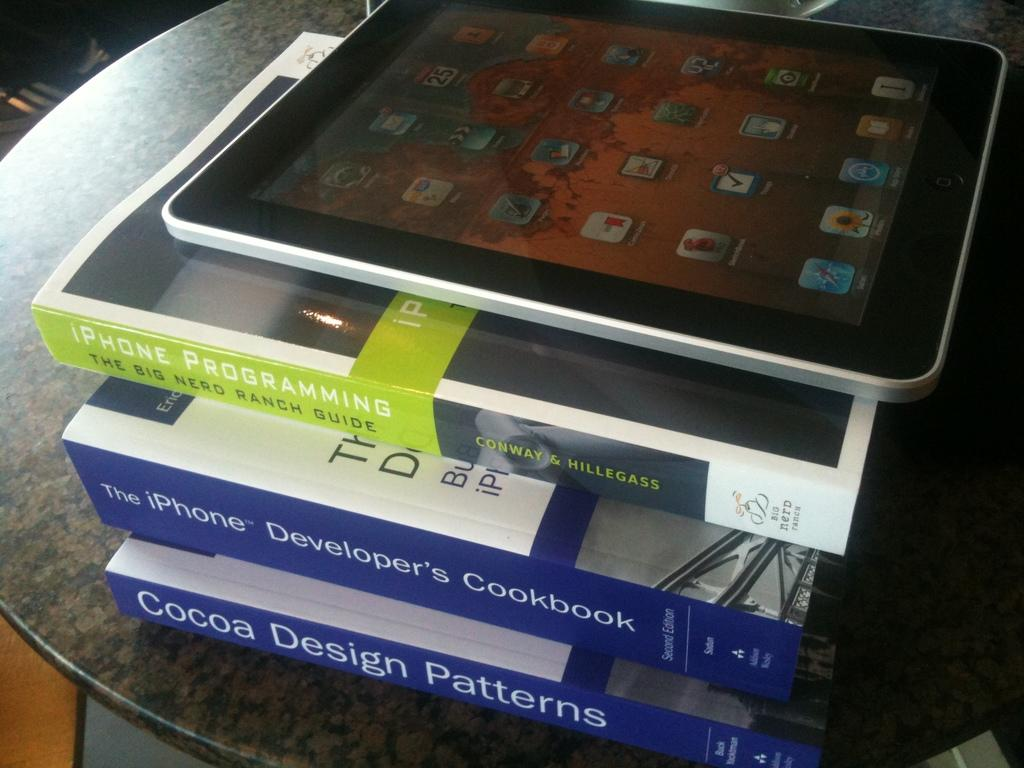<image>
Offer a succinct explanation of the picture presented. an iphone on top of a stack of books with one of them called 'iphone programming' 